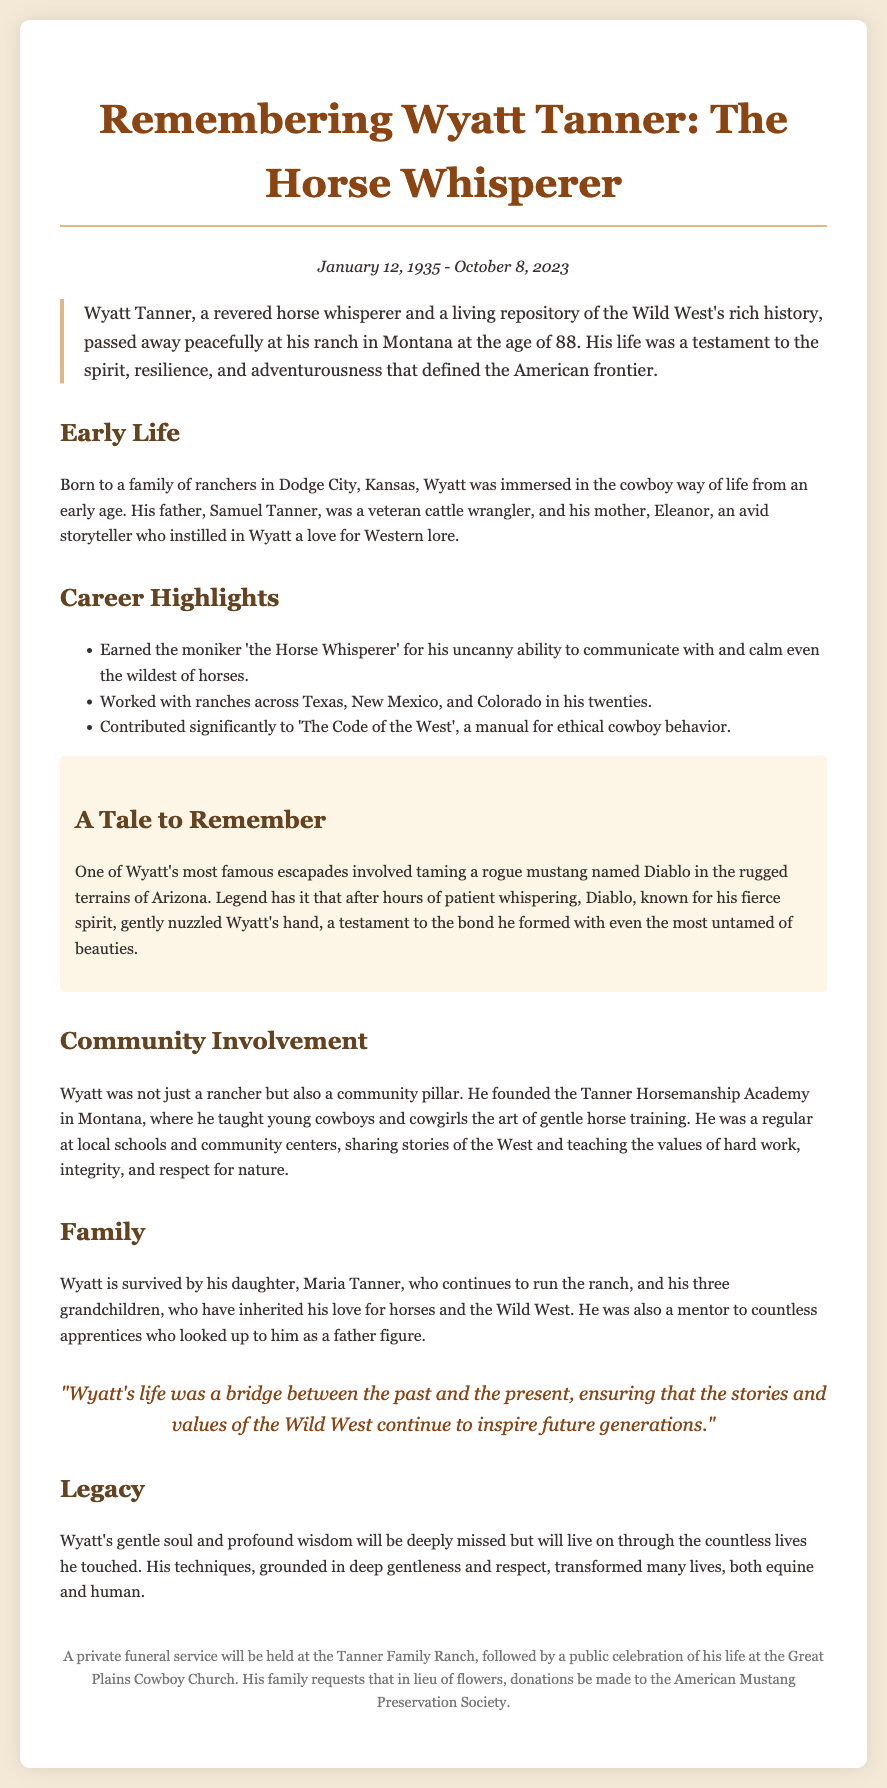What was Wyatt Tanner's age at the time of his passing? Wyatt Tanner passed away at the age of 88, which can be calculated by subtracting his birth year, 1935, from the year of his death, 2023.
Answer: 88 Where was Wyatt Tanner born? The document states that Wyatt was born in Dodge City, Kansas, providing a geographic context to his early life.
Answer: Dodge City, Kansas What did Wyatt Tanner earn the moniker 'the Horse Whisperer' for? The document explains that Wyatt earned this title for his uncanny ability to communicate with and calm even the wildest of horses, indicating his unique skills.
Answer: His ability to communicate with horses What significant contribution did Wyatt make related to cowboy behavior? The document mentions that Wyatt contributed significantly to 'The Code of the West', which outlines ethical cowboy behavior, indicating his impact on the ranching community.
Answer: 'The Code of the West' Who is Wyatt Tanner survived by? The document lists his daughter, Maria Tanner, and his three grandchildren as his survivors, reflecting his family connections and legacy.
Answer: Maria Tanner and three grandchildren What type of academy did Wyatt Tanner found? The document states that Wyatt founded the Tanner Horsemanship Academy, which was focused on teaching horsemanship skills, highlighting his dedication to mentorship.
Answer: Tanner Horsemanship Academy What was Wyatt Tanner known for in the Wild West? The document describes Wyatt Tanner as a living repository of the Wild West's rich history, illustrating his significance in preserving Western traditions.
Answer: His rich history of the Wild West What did Wyatt Tanner do in local communities? According to the document, Wyatt was a regular at local schools and community centers sharing stories of the West, indicating his involvement and influence in the community.
Answer: Shared stories of the West What special event is mentioned in relation to his funeral? The document mentions a private funeral service followed by a public celebration of his life, emphasizing the significance of his legacy and community ties.
Answer: A public celebration of his life at the Great Plains Cowboy Church 